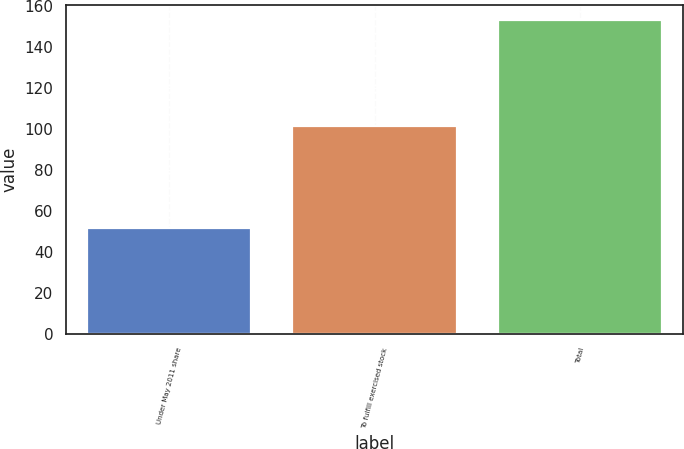Convert chart to OTSL. <chart><loc_0><loc_0><loc_500><loc_500><bar_chart><fcel>Under May 2011 share<fcel>To fulfill exercised stock<fcel>Total<nl><fcel>51.8<fcel>101.4<fcel>153.2<nl></chart> 